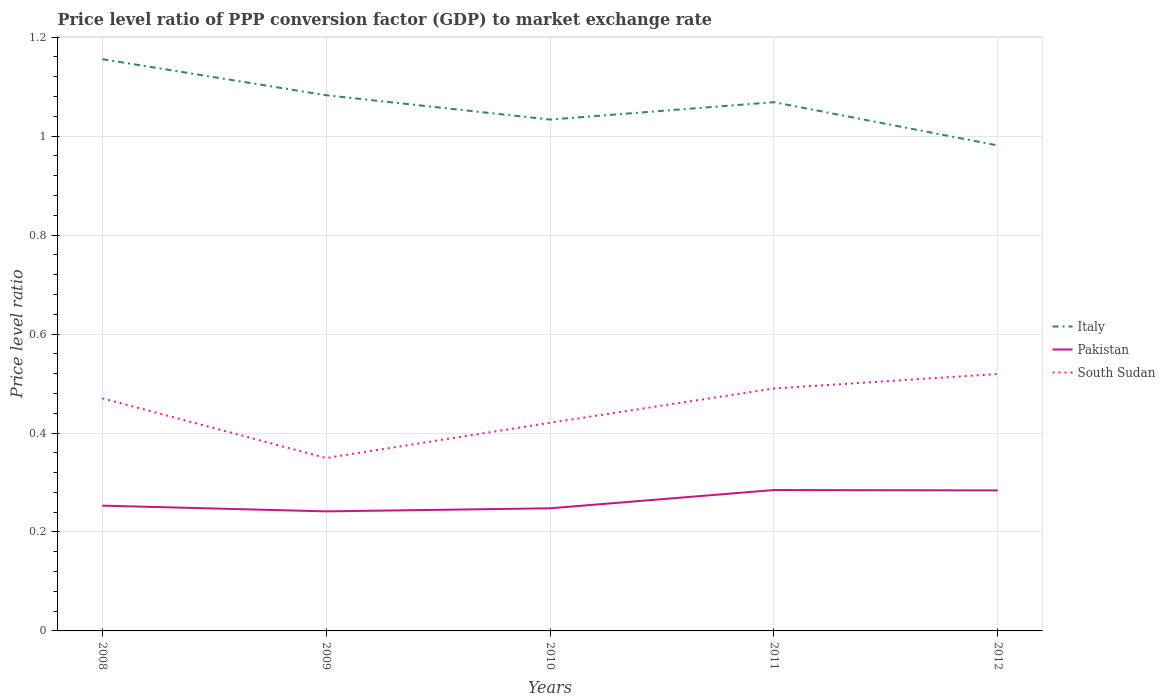How many different coloured lines are there?
Offer a very short reply. 3. Is the number of lines equal to the number of legend labels?
Offer a terse response. Yes. Across all years, what is the maximum price level ratio in Pakistan?
Provide a succinct answer. 0.24. In which year was the price level ratio in Italy maximum?
Keep it short and to the point. 2012. What is the total price level ratio in Pakistan in the graph?
Ensure brevity in your answer.  0.01. What is the difference between the highest and the second highest price level ratio in Pakistan?
Keep it short and to the point. 0.04. What is the difference between two consecutive major ticks on the Y-axis?
Offer a very short reply. 0.2. Are the values on the major ticks of Y-axis written in scientific E-notation?
Offer a very short reply. No. How many legend labels are there?
Provide a short and direct response. 3. What is the title of the graph?
Provide a short and direct response. Price level ratio of PPP conversion factor (GDP) to market exchange rate. What is the label or title of the X-axis?
Keep it short and to the point. Years. What is the label or title of the Y-axis?
Keep it short and to the point. Price level ratio. What is the Price level ratio of Italy in 2008?
Ensure brevity in your answer.  1.16. What is the Price level ratio of Pakistan in 2008?
Your answer should be compact. 0.25. What is the Price level ratio of South Sudan in 2008?
Ensure brevity in your answer.  0.47. What is the Price level ratio of Italy in 2009?
Make the answer very short. 1.08. What is the Price level ratio of Pakistan in 2009?
Provide a short and direct response. 0.24. What is the Price level ratio of South Sudan in 2009?
Offer a very short reply. 0.35. What is the Price level ratio in Italy in 2010?
Provide a succinct answer. 1.03. What is the Price level ratio in Pakistan in 2010?
Give a very brief answer. 0.25. What is the Price level ratio in South Sudan in 2010?
Your answer should be compact. 0.42. What is the Price level ratio in Italy in 2011?
Keep it short and to the point. 1.07. What is the Price level ratio of Pakistan in 2011?
Your answer should be very brief. 0.28. What is the Price level ratio in South Sudan in 2011?
Your answer should be very brief. 0.49. What is the Price level ratio in Italy in 2012?
Offer a terse response. 0.98. What is the Price level ratio of Pakistan in 2012?
Your answer should be compact. 0.28. What is the Price level ratio of South Sudan in 2012?
Offer a terse response. 0.52. Across all years, what is the maximum Price level ratio of Italy?
Give a very brief answer. 1.16. Across all years, what is the maximum Price level ratio of Pakistan?
Provide a short and direct response. 0.28. Across all years, what is the maximum Price level ratio of South Sudan?
Offer a terse response. 0.52. Across all years, what is the minimum Price level ratio in Italy?
Give a very brief answer. 0.98. Across all years, what is the minimum Price level ratio of Pakistan?
Your answer should be very brief. 0.24. Across all years, what is the minimum Price level ratio in South Sudan?
Your answer should be very brief. 0.35. What is the total Price level ratio of Italy in the graph?
Provide a short and direct response. 5.32. What is the total Price level ratio in Pakistan in the graph?
Make the answer very short. 1.31. What is the total Price level ratio of South Sudan in the graph?
Your answer should be very brief. 2.25. What is the difference between the Price level ratio in Italy in 2008 and that in 2009?
Give a very brief answer. 0.07. What is the difference between the Price level ratio of Pakistan in 2008 and that in 2009?
Keep it short and to the point. 0.01. What is the difference between the Price level ratio in South Sudan in 2008 and that in 2009?
Provide a succinct answer. 0.12. What is the difference between the Price level ratio in Italy in 2008 and that in 2010?
Your response must be concise. 0.12. What is the difference between the Price level ratio in Pakistan in 2008 and that in 2010?
Offer a very short reply. 0.01. What is the difference between the Price level ratio of South Sudan in 2008 and that in 2010?
Ensure brevity in your answer.  0.05. What is the difference between the Price level ratio in Italy in 2008 and that in 2011?
Ensure brevity in your answer.  0.09. What is the difference between the Price level ratio in Pakistan in 2008 and that in 2011?
Give a very brief answer. -0.03. What is the difference between the Price level ratio in South Sudan in 2008 and that in 2011?
Make the answer very short. -0.02. What is the difference between the Price level ratio of Italy in 2008 and that in 2012?
Provide a succinct answer. 0.17. What is the difference between the Price level ratio of Pakistan in 2008 and that in 2012?
Offer a very short reply. -0.03. What is the difference between the Price level ratio of South Sudan in 2008 and that in 2012?
Keep it short and to the point. -0.05. What is the difference between the Price level ratio of Italy in 2009 and that in 2010?
Give a very brief answer. 0.05. What is the difference between the Price level ratio of Pakistan in 2009 and that in 2010?
Provide a short and direct response. -0.01. What is the difference between the Price level ratio in South Sudan in 2009 and that in 2010?
Ensure brevity in your answer.  -0.07. What is the difference between the Price level ratio in Italy in 2009 and that in 2011?
Offer a very short reply. 0.01. What is the difference between the Price level ratio in Pakistan in 2009 and that in 2011?
Your answer should be compact. -0.04. What is the difference between the Price level ratio of South Sudan in 2009 and that in 2011?
Ensure brevity in your answer.  -0.14. What is the difference between the Price level ratio of Italy in 2009 and that in 2012?
Offer a very short reply. 0.1. What is the difference between the Price level ratio of Pakistan in 2009 and that in 2012?
Give a very brief answer. -0.04. What is the difference between the Price level ratio of South Sudan in 2009 and that in 2012?
Your answer should be compact. -0.17. What is the difference between the Price level ratio of Italy in 2010 and that in 2011?
Ensure brevity in your answer.  -0.04. What is the difference between the Price level ratio in Pakistan in 2010 and that in 2011?
Your answer should be very brief. -0.04. What is the difference between the Price level ratio of South Sudan in 2010 and that in 2011?
Offer a very short reply. -0.07. What is the difference between the Price level ratio in Italy in 2010 and that in 2012?
Make the answer very short. 0.05. What is the difference between the Price level ratio in Pakistan in 2010 and that in 2012?
Ensure brevity in your answer.  -0.04. What is the difference between the Price level ratio of South Sudan in 2010 and that in 2012?
Ensure brevity in your answer.  -0.1. What is the difference between the Price level ratio of Italy in 2011 and that in 2012?
Give a very brief answer. 0.09. What is the difference between the Price level ratio of Pakistan in 2011 and that in 2012?
Your answer should be very brief. 0. What is the difference between the Price level ratio in South Sudan in 2011 and that in 2012?
Your answer should be very brief. -0.03. What is the difference between the Price level ratio in Italy in 2008 and the Price level ratio in Pakistan in 2009?
Your answer should be very brief. 0.91. What is the difference between the Price level ratio of Italy in 2008 and the Price level ratio of South Sudan in 2009?
Offer a very short reply. 0.81. What is the difference between the Price level ratio in Pakistan in 2008 and the Price level ratio in South Sudan in 2009?
Ensure brevity in your answer.  -0.1. What is the difference between the Price level ratio in Italy in 2008 and the Price level ratio in Pakistan in 2010?
Give a very brief answer. 0.91. What is the difference between the Price level ratio of Italy in 2008 and the Price level ratio of South Sudan in 2010?
Your answer should be very brief. 0.73. What is the difference between the Price level ratio in Pakistan in 2008 and the Price level ratio in South Sudan in 2010?
Provide a succinct answer. -0.17. What is the difference between the Price level ratio of Italy in 2008 and the Price level ratio of Pakistan in 2011?
Provide a short and direct response. 0.87. What is the difference between the Price level ratio of Italy in 2008 and the Price level ratio of South Sudan in 2011?
Your answer should be compact. 0.67. What is the difference between the Price level ratio of Pakistan in 2008 and the Price level ratio of South Sudan in 2011?
Your answer should be very brief. -0.24. What is the difference between the Price level ratio in Italy in 2008 and the Price level ratio in Pakistan in 2012?
Provide a short and direct response. 0.87. What is the difference between the Price level ratio of Italy in 2008 and the Price level ratio of South Sudan in 2012?
Your answer should be compact. 0.64. What is the difference between the Price level ratio of Pakistan in 2008 and the Price level ratio of South Sudan in 2012?
Your answer should be compact. -0.27. What is the difference between the Price level ratio in Italy in 2009 and the Price level ratio in Pakistan in 2010?
Give a very brief answer. 0.83. What is the difference between the Price level ratio in Italy in 2009 and the Price level ratio in South Sudan in 2010?
Your answer should be very brief. 0.66. What is the difference between the Price level ratio of Pakistan in 2009 and the Price level ratio of South Sudan in 2010?
Offer a terse response. -0.18. What is the difference between the Price level ratio of Italy in 2009 and the Price level ratio of Pakistan in 2011?
Make the answer very short. 0.8. What is the difference between the Price level ratio of Italy in 2009 and the Price level ratio of South Sudan in 2011?
Ensure brevity in your answer.  0.59. What is the difference between the Price level ratio in Pakistan in 2009 and the Price level ratio in South Sudan in 2011?
Offer a terse response. -0.25. What is the difference between the Price level ratio in Italy in 2009 and the Price level ratio in Pakistan in 2012?
Offer a terse response. 0.8. What is the difference between the Price level ratio of Italy in 2009 and the Price level ratio of South Sudan in 2012?
Provide a short and direct response. 0.56. What is the difference between the Price level ratio in Pakistan in 2009 and the Price level ratio in South Sudan in 2012?
Provide a short and direct response. -0.28. What is the difference between the Price level ratio in Italy in 2010 and the Price level ratio in Pakistan in 2011?
Give a very brief answer. 0.75. What is the difference between the Price level ratio of Italy in 2010 and the Price level ratio of South Sudan in 2011?
Give a very brief answer. 0.54. What is the difference between the Price level ratio in Pakistan in 2010 and the Price level ratio in South Sudan in 2011?
Offer a very short reply. -0.24. What is the difference between the Price level ratio of Italy in 2010 and the Price level ratio of Pakistan in 2012?
Offer a very short reply. 0.75. What is the difference between the Price level ratio in Italy in 2010 and the Price level ratio in South Sudan in 2012?
Your answer should be compact. 0.51. What is the difference between the Price level ratio in Pakistan in 2010 and the Price level ratio in South Sudan in 2012?
Give a very brief answer. -0.27. What is the difference between the Price level ratio of Italy in 2011 and the Price level ratio of Pakistan in 2012?
Provide a short and direct response. 0.78. What is the difference between the Price level ratio of Italy in 2011 and the Price level ratio of South Sudan in 2012?
Your response must be concise. 0.55. What is the difference between the Price level ratio of Pakistan in 2011 and the Price level ratio of South Sudan in 2012?
Keep it short and to the point. -0.23. What is the average Price level ratio in Italy per year?
Your answer should be very brief. 1.06. What is the average Price level ratio in Pakistan per year?
Provide a short and direct response. 0.26. What is the average Price level ratio of South Sudan per year?
Your answer should be compact. 0.45. In the year 2008, what is the difference between the Price level ratio in Italy and Price level ratio in Pakistan?
Your answer should be compact. 0.9. In the year 2008, what is the difference between the Price level ratio in Italy and Price level ratio in South Sudan?
Give a very brief answer. 0.69. In the year 2008, what is the difference between the Price level ratio in Pakistan and Price level ratio in South Sudan?
Provide a succinct answer. -0.22. In the year 2009, what is the difference between the Price level ratio of Italy and Price level ratio of Pakistan?
Provide a succinct answer. 0.84. In the year 2009, what is the difference between the Price level ratio of Italy and Price level ratio of South Sudan?
Your answer should be very brief. 0.73. In the year 2009, what is the difference between the Price level ratio of Pakistan and Price level ratio of South Sudan?
Give a very brief answer. -0.11. In the year 2010, what is the difference between the Price level ratio in Italy and Price level ratio in Pakistan?
Offer a terse response. 0.79. In the year 2010, what is the difference between the Price level ratio of Italy and Price level ratio of South Sudan?
Make the answer very short. 0.61. In the year 2010, what is the difference between the Price level ratio in Pakistan and Price level ratio in South Sudan?
Give a very brief answer. -0.17. In the year 2011, what is the difference between the Price level ratio of Italy and Price level ratio of Pakistan?
Your answer should be very brief. 0.78. In the year 2011, what is the difference between the Price level ratio in Italy and Price level ratio in South Sudan?
Your response must be concise. 0.58. In the year 2011, what is the difference between the Price level ratio in Pakistan and Price level ratio in South Sudan?
Your response must be concise. -0.21. In the year 2012, what is the difference between the Price level ratio in Italy and Price level ratio in Pakistan?
Offer a terse response. 0.7. In the year 2012, what is the difference between the Price level ratio of Italy and Price level ratio of South Sudan?
Ensure brevity in your answer.  0.46. In the year 2012, what is the difference between the Price level ratio in Pakistan and Price level ratio in South Sudan?
Offer a terse response. -0.24. What is the ratio of the Price level ratio of Italy in 2008 to that in 2009?
Make the answer very short. 1.07. What is the ratio of the Price level ratio of Pakistan in 2008 to that in 2009?
Make the answer very short. 1.05. What is the ratio of the Price level ratio in South Sudan in 2008 to that in 2009?
Make the answer very short. 1.35. What is the ratio of the Price level ratio in Italy in 2008 to that in 2010?
Offer a terse response. 1.12. What is the ratio of the Price level ratio in Pakistan in 2008 to that in 2010?
Ensure brevity in your answer.  1.02. What is the ratio of the Price level ratio in South Sudan in 2008 to that in 2010?
Keep it short and to the point. 1.12. What is the ratio of the Price level ratio in Italy in 2008 to that in 2011?
Keep it short and to the point. 1.08. What is the ratio of the Price level ratio in Pakistan in 2008 to that in 2011?
Keep it short and to the point. 0.89. What is the ratio of the Price level ratio in South Sudan in 2008 to that in 2011?
Provide a short and direct response. 0.96. What is the ratio of the Price level ratio in Italy in 2008 to that in 2012?
Keep it short and to the point. 1.18. What is the ratio of the Price level ratio of Pakistan in 2008 to that in 2012?
Your response must be concise. 0.89. What is the ratio of the Price level ratio in South Sudan in 2008 to that in 2012?
Your answer should be very brief. 0.91. What is the ratio of the Price level ratio of Italy in 2009 to that in 2010?
Provide a short and direct response. 1.05. What is the ratio of the Price level ratio in Pakistan in 2009 to that in 2010?
Provide a short and direct response. 0.97. What is the ratio of the Price level ratio of South Sudan in 2009 to that in 2010?
Offer a very short reply. 0.83. What is the ratio of the Price level ratio of Italy in 2009 to that in 2011?
Ensure brevity in your answer.  1.01. What is the ratio of the Price level ratio in Pakistan in 2009 to that in 2011?
Make the answer very short. 0.85. What is the ratio of the Price level ratio of South Sudan in 2009 to that in 2011?
Offer a very short reply. 0.71. What is the ratio of the Price level ratio in Italy in 2009 to that in 2012?
Offer a very short reply. 1.1. What is the ratio of the Price level ratio of Pakistan in 2009 to that in 2012?
Keep it short and to the point. 0.85. What is the ratio of the Price level ratio of South Sudan in 2009 to that in 2012?
Provide a short and direct response. 0.67. What is the ratio of the Price level ratio in Italy in 2010 to that in 2011?
Your response must be concise. 0.97. What is the ratio of the Price level ratio of Pakistan in 2010 to that in 2011?
Provide a short and direct response. 0.87. What is the ratio of the Price level ratio of South Sudan in 2010 to that in 2011?
Your response must be concise. 0.86. What is the ratio of the Price level ratio in Italy in 2010 to that in 2012?
Keep it short and to the point. 1.05. What is the ratio of the Price level ratio in Pakistan in 2010 to that in 2012?
Offer a very short reply. 0.87. What is the ratio of the Price level ratio of South Sudan in 2010 to that in 2012?
Ensure brevity in your answer.  0.81. What is the ratio of the Price level ratio of Italy in 2011 to that in 2012?
Your response must be concise. 1.09. What is the ratio of the Price level ratio of Pakistan in 2011 to that in 2012?
Provide a succinct answer. 1. What is the ratio of the Price level ratio of South Sudan in 2011 to that in 2012?
Keep it short and to the point. 0.94. What is the difference between the highest and the second highest Price level ratio in Italy?
Provide a short and direct response. 0.07. What is the difference between the highest and the second highest Price level ratio in Pakistan?
Provide a succinct answer. 0. What is the difference between the highest and the second highest Price level ratio in South Sudan?
Provide a succinct answer. 0.03. What is the difference between the highest and the lowest Price level ratio in Italy?
Give a very brief answer. 0.17. What is the difference between the highest and the lowest Price level ratio of Pakistan?
Your response must be concise. 0.04. What is the difference between the highest and the lowest Price level ratio in South Sudan?
Ensure brevity in your answer.  0.17. 